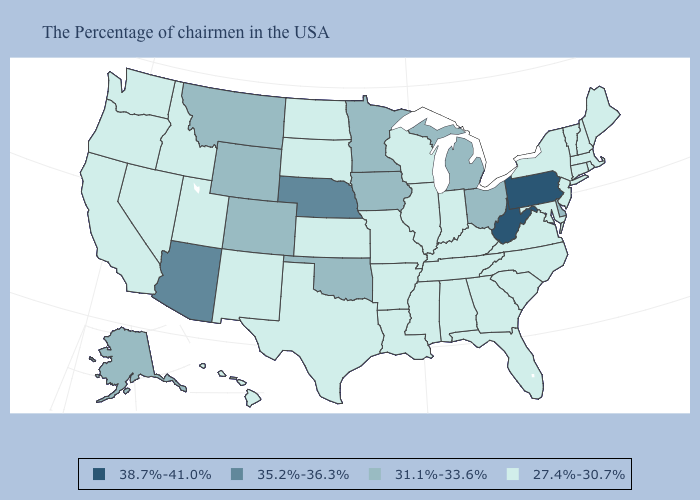Does Hawaii have the lowest value in the USA?
Answer briefly. Yes. Which states hav the highest value in the Northeast?
Answer briefly. Pennsylvania. Among the states that border Indiana , does Michigan have the highest value?
Keep it brief. Yes. What is the lowest value in the MidWest?
Answer briefly. 27.4%-30.7%. Which states have the lowest value in the USA?
Short answer required. Maine, Massachusetts, Rhode Island, New Hampshire, Vermont, Connecticut, New York, New Jersey, Maryland, Virginia, North Carolina, South Carolina, Florida, Georgia, Kentucky, Indiana, Alabama, Tennessee, Wisconsin, Illinois, Mississippi, Louisiana, Missouri, Arkansas, Kansas, Texas, South Dakota, North Dakota, New Mexico, Utah, Idaho, Nevada, California, Washington, Oregon, Hawaii. Name the states that have a value in the range 27.4%-30.7%?
Concise answer only. Maine, Massachusetts, Rhode Island, New Hampshire, Vermont, Connecticut, New York, New Jersey, Maryland, Virginia, North Carolina, South Carolina, Florida, Georgia, Kentucky, Indiana, Alabama, Tennessee, Wisconsin, Illinois, Mississippi, Louisiana, Missouri, Arkansas, Kansas, Texas, South Dakota, North Dakota, New Mexico, Utah, Idaho, Nevada, California, Washington, Oregon, Hawaii. Does the first symbol in the legend represent the smallest category?
Be succinct. No. Does Tennessee have the same value as Oregon?
Give a very brief answer. Yes. Does the map have missing data?
Short answer required. No. Name the states that have a value in the range 35.2%-36.3%?
Answer briefly. Nebraska, Arizona. Is the legend a continuous bar?
Keep it brief. No. Among the states that border West Virginia , does Kentucky have the lowest value?
Quick response, please. Yes. What is the lowest value in the USA?
Give a very brief answer. 27.4%-30.7%. Name the states that have a value in the range 27.4%-30.7%?
Give a very brief answer. Maine, Massachusetts, Rhode Island, New Hampshire, Vermont, Connecticut, New York, New Jersey, Maryland, Virginia, North Carolina, South Carolina, Florida, Georgia, Kentucky, Indiana, Alabama, Tennessee, Wisconsin, Illinois, Mississippi, Louisiana, Missouri, Arkansas, Kansas, Texas, South Dakota, North Dakota, New Mexico, Utah, Idaho, Nevada, California, Washington, Oregon, Hawaii. 